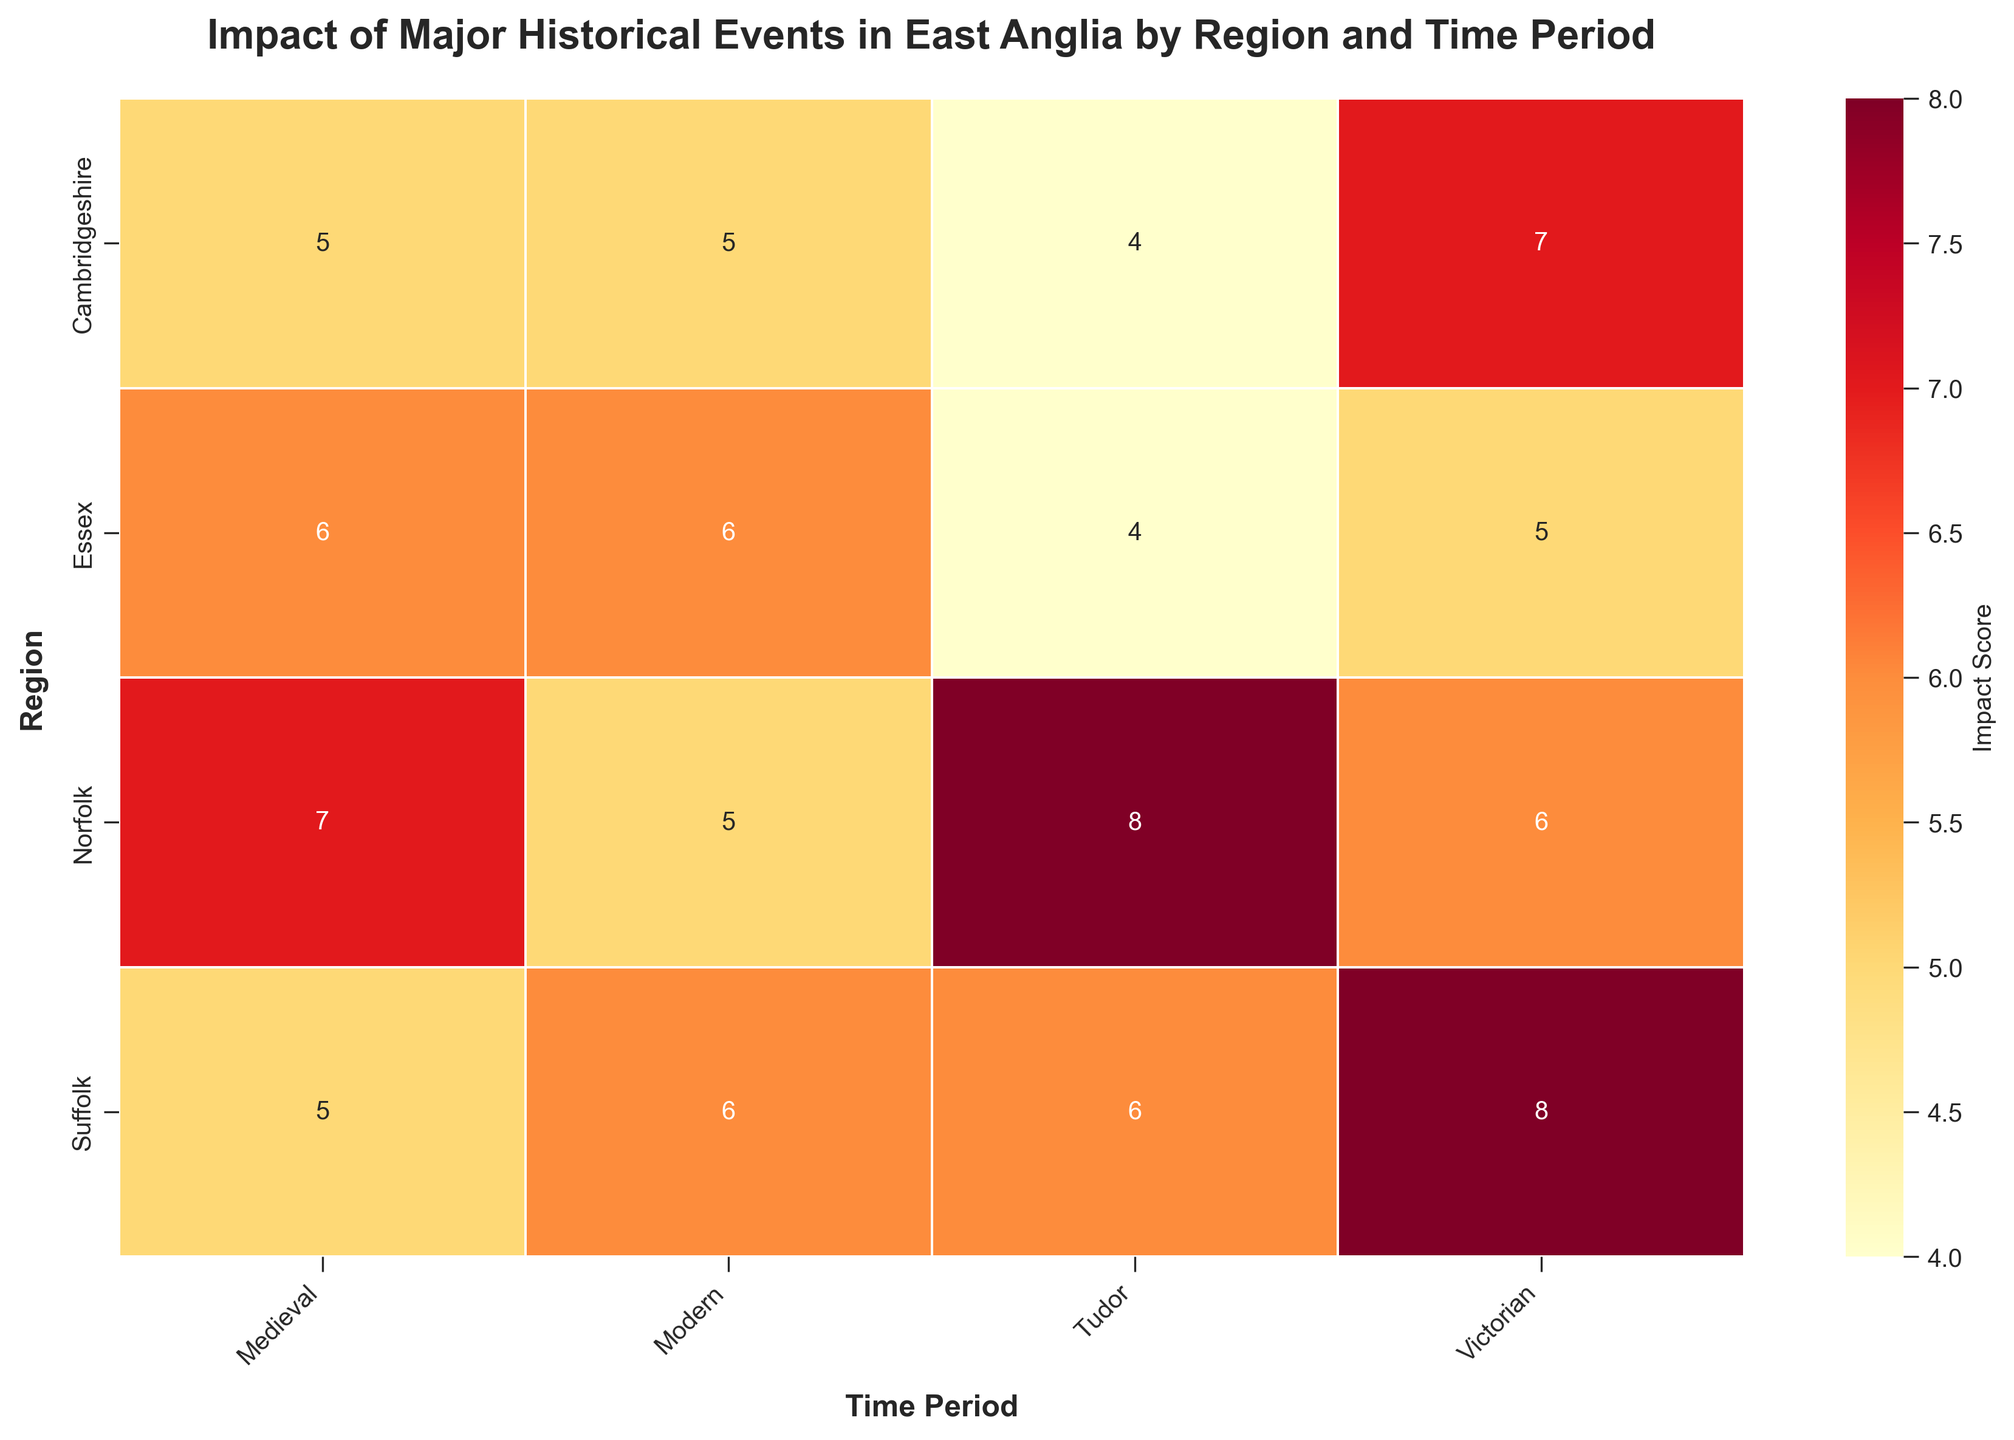Which region has the highest impact score in the Victorian period? Look at the Victorian column and find the highest impact score. Suffolk has the highest impact score of 8.
Answer: Suffolk What is the range of impact scores for Norfolk across all time periods? List the impact scores for Norfolk across Medieval, Tudor, Victorian, and Modern: 7, 8, 6, and 5. The range is the difference between the maximum (8) and minimum (5) scores.
Answer: 3 Which time period had the most consistent impact scores across all regions? Compare the variation in impact scores across regions for each time period. The Tudor period has similar impact scores across all regions (3, 4, 4, and 6).
Answer: Tudor Is the impact score for Suffolk in the Victorian period higher than in the Tudor period? Compare the impact scores for Suffolk in the Victorian period (8) and Tudor period (6). Yes, 8 is higher than 6.
Answer: Yes What is the sum of impact scores for Cambridgeshire across all time periods? Add the impact scores for Cambridgeshire for Medieval, Tudor, Victorian, and Modern periods: 5 + 4 + 7 + 5 = 21.
Answer: 21 How does the impact score in the Medieval period for Essex compare to Norfolk? Compare the impact scores. Essex has 6 while Norfolk has 7 in the Medieval period; Essex’s score is lower.
Answer: Lower Which region has the lowest impact score in the modern period? Look at the Modern column and find the lowest impact score, which is 5 for Norfolk and Cambridgeshire.
Answer: Norfolk & Cambridgeshire What is the average impact score for the Tudor period across all regions? Add the impact scores for the Tudor period (Norfolk: 8, Suffolk: 6, Cambridgeshire: 4, Essex: 4), then divide by the number of regions (4). (8 + 6 + 4 + 4) / 4 = 5.5.
Answer: 5.5 Which region shows the greatest increase in impact score from the Medieval to the Victorian period? Calculate the increase for each region by subtracting the Medieval score from the Victorian score: Norfolk (-1), Suffolk (3), Cambridgeshire (2), Essex (-1). Suffolk has the greatest increase.
Answer: Suffolk 